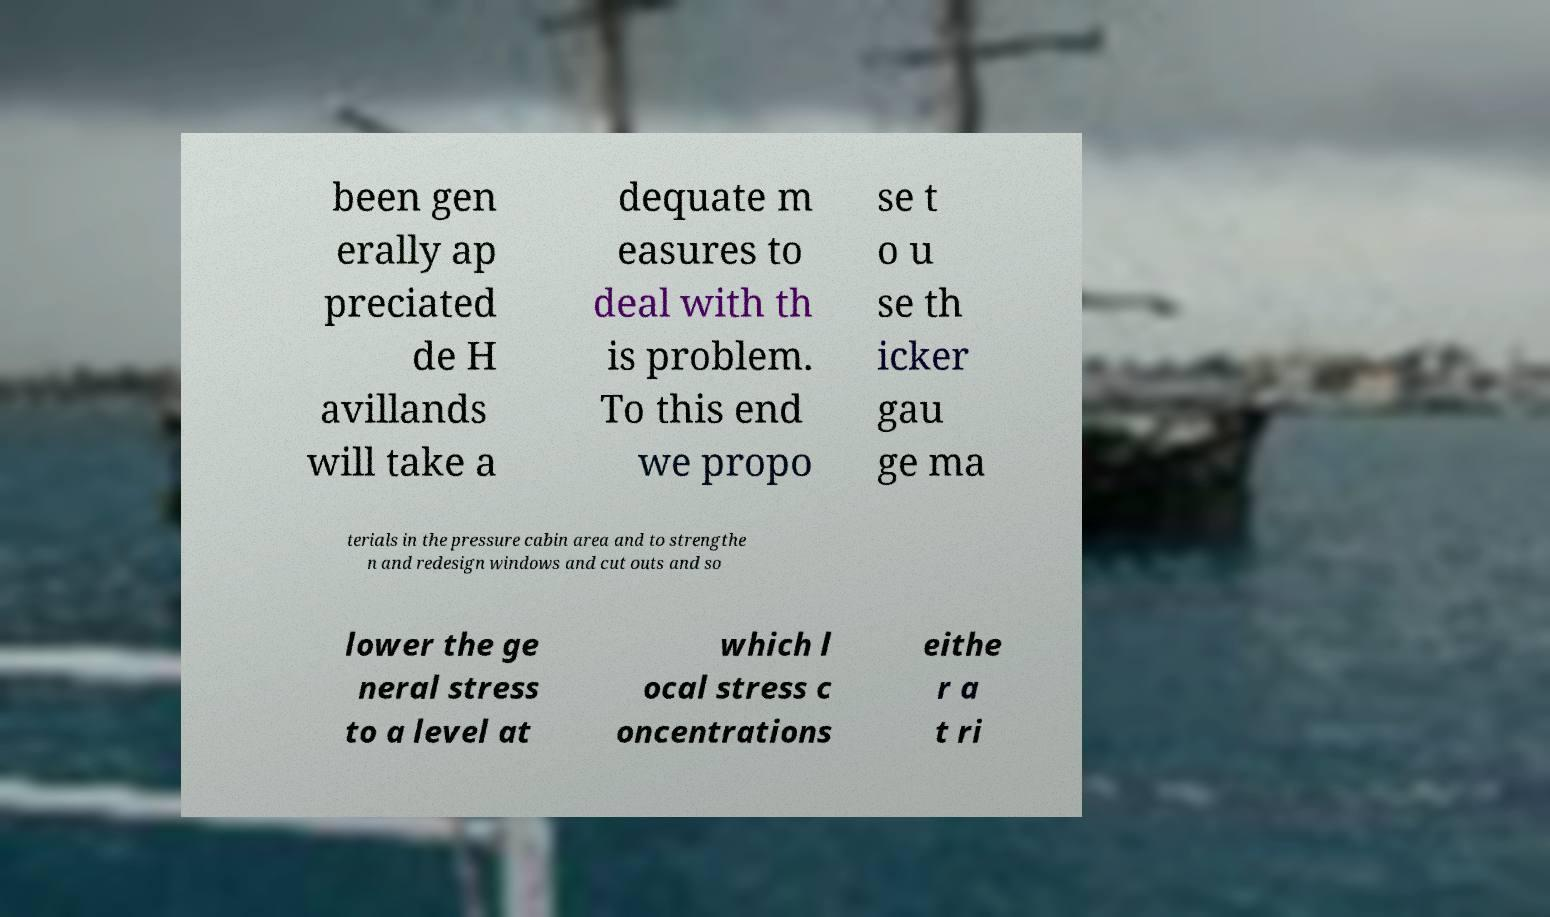Please read and relay the text visible in this image. What does it say? been gen erally ap preciated de H avillands will take a dequate m easures to deal with th is problem. To this end we propo se t o u se th icker gau ge ma terials in the pressure cabin area and to strengthe n and redesign windows and cut outs and so lower the ge neral stress to a level at which l ocal stress c oncentrations eithe r a t ri 